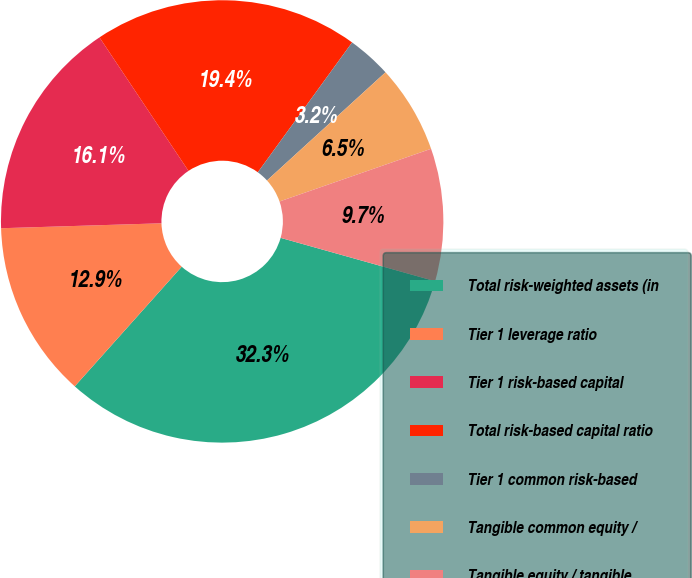<chart> <loc_0><loc_0><loc_500><loc_500><pie_chart><fcel>Total risk-weighted assets (in<fcel>Tier 1 leverage ratio<fcel>Tier 1 risk-based capital<fcel>Total risk-based capital ratio<fcel>Tier 1 common risk-based<fcel>Tangible common equity /<fcel>Tangible equity / tangible<nl><fcel>32.25%<fcel>12.9%<fcel>16.13%<fcel>19.35%<fcel>3.23%<fcel>6.45%<fcel>9.68%<nl></chart> 